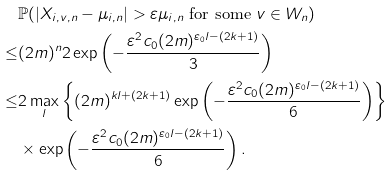<formula> <loc_0><loc_0><loc_500><loc_500>& \mathbb { P } ( | X _ { i , v , n } - \mu _ { i , n } | > \varepsilon \mu _ { i , n } \text { for some } v \in W _ { n } ) \\ \leq & ( 2 m ) ^ { n } 2 \exp \left ( - \frac { \varepsilon ^ { 2 } c _ { 0 } ( 2 m ) ^ { \varepsilon _ { 0 } l - ( 2 k + 1 ) } } { 3 } \right ) \\ \leq & 2 \max _ { l } \left \{ ( 2 m ) ^ { k l + ( 2 k + 1 ) } \exp \left ( - \frac { \varepsilon ^ { 2 } c _ { 0 } ( 2 m ) ^ { \varepsilon _ { 0 } l - ( 2 k + 1 ) } } { 6 } \right ) \right \} \\ & \times \exp \left ( - \frac { \varepsilon ^ { 2 } c _ { 0 } ( 2 m ) ^ { \varepsilon _ { 0 } l - ( 2 k + 1 ) } } { 6 } \right ) .</formula> 